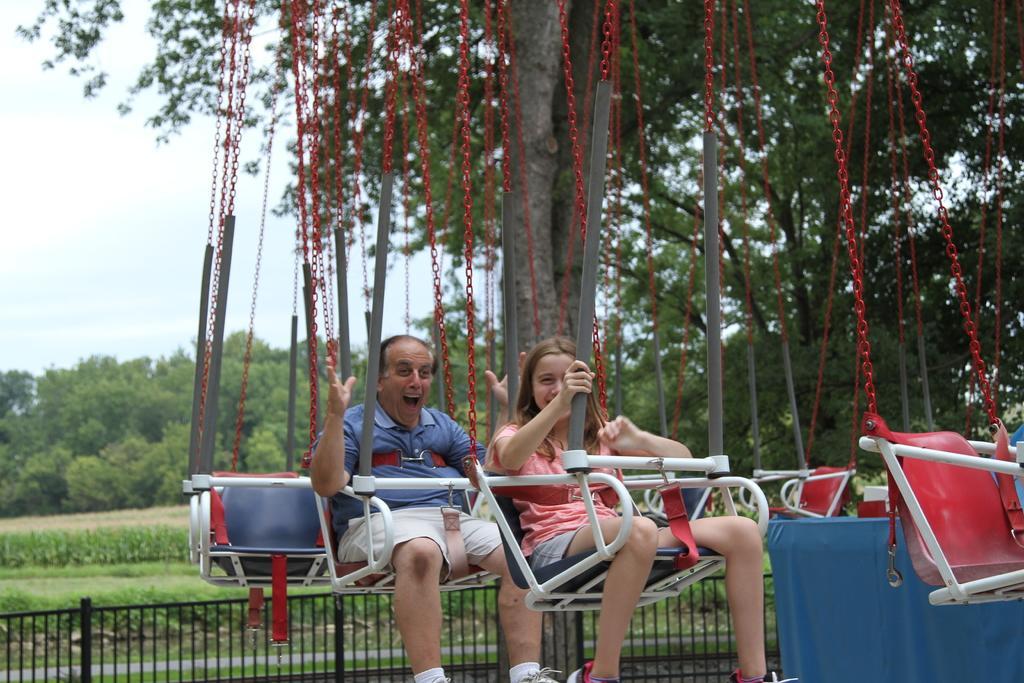Please provide a concise description of this image. In this picture I can see a man and a woman are sitting on an object and smiling. In the background I can see fence, grass and the sky. On the right side I can see some objects. 